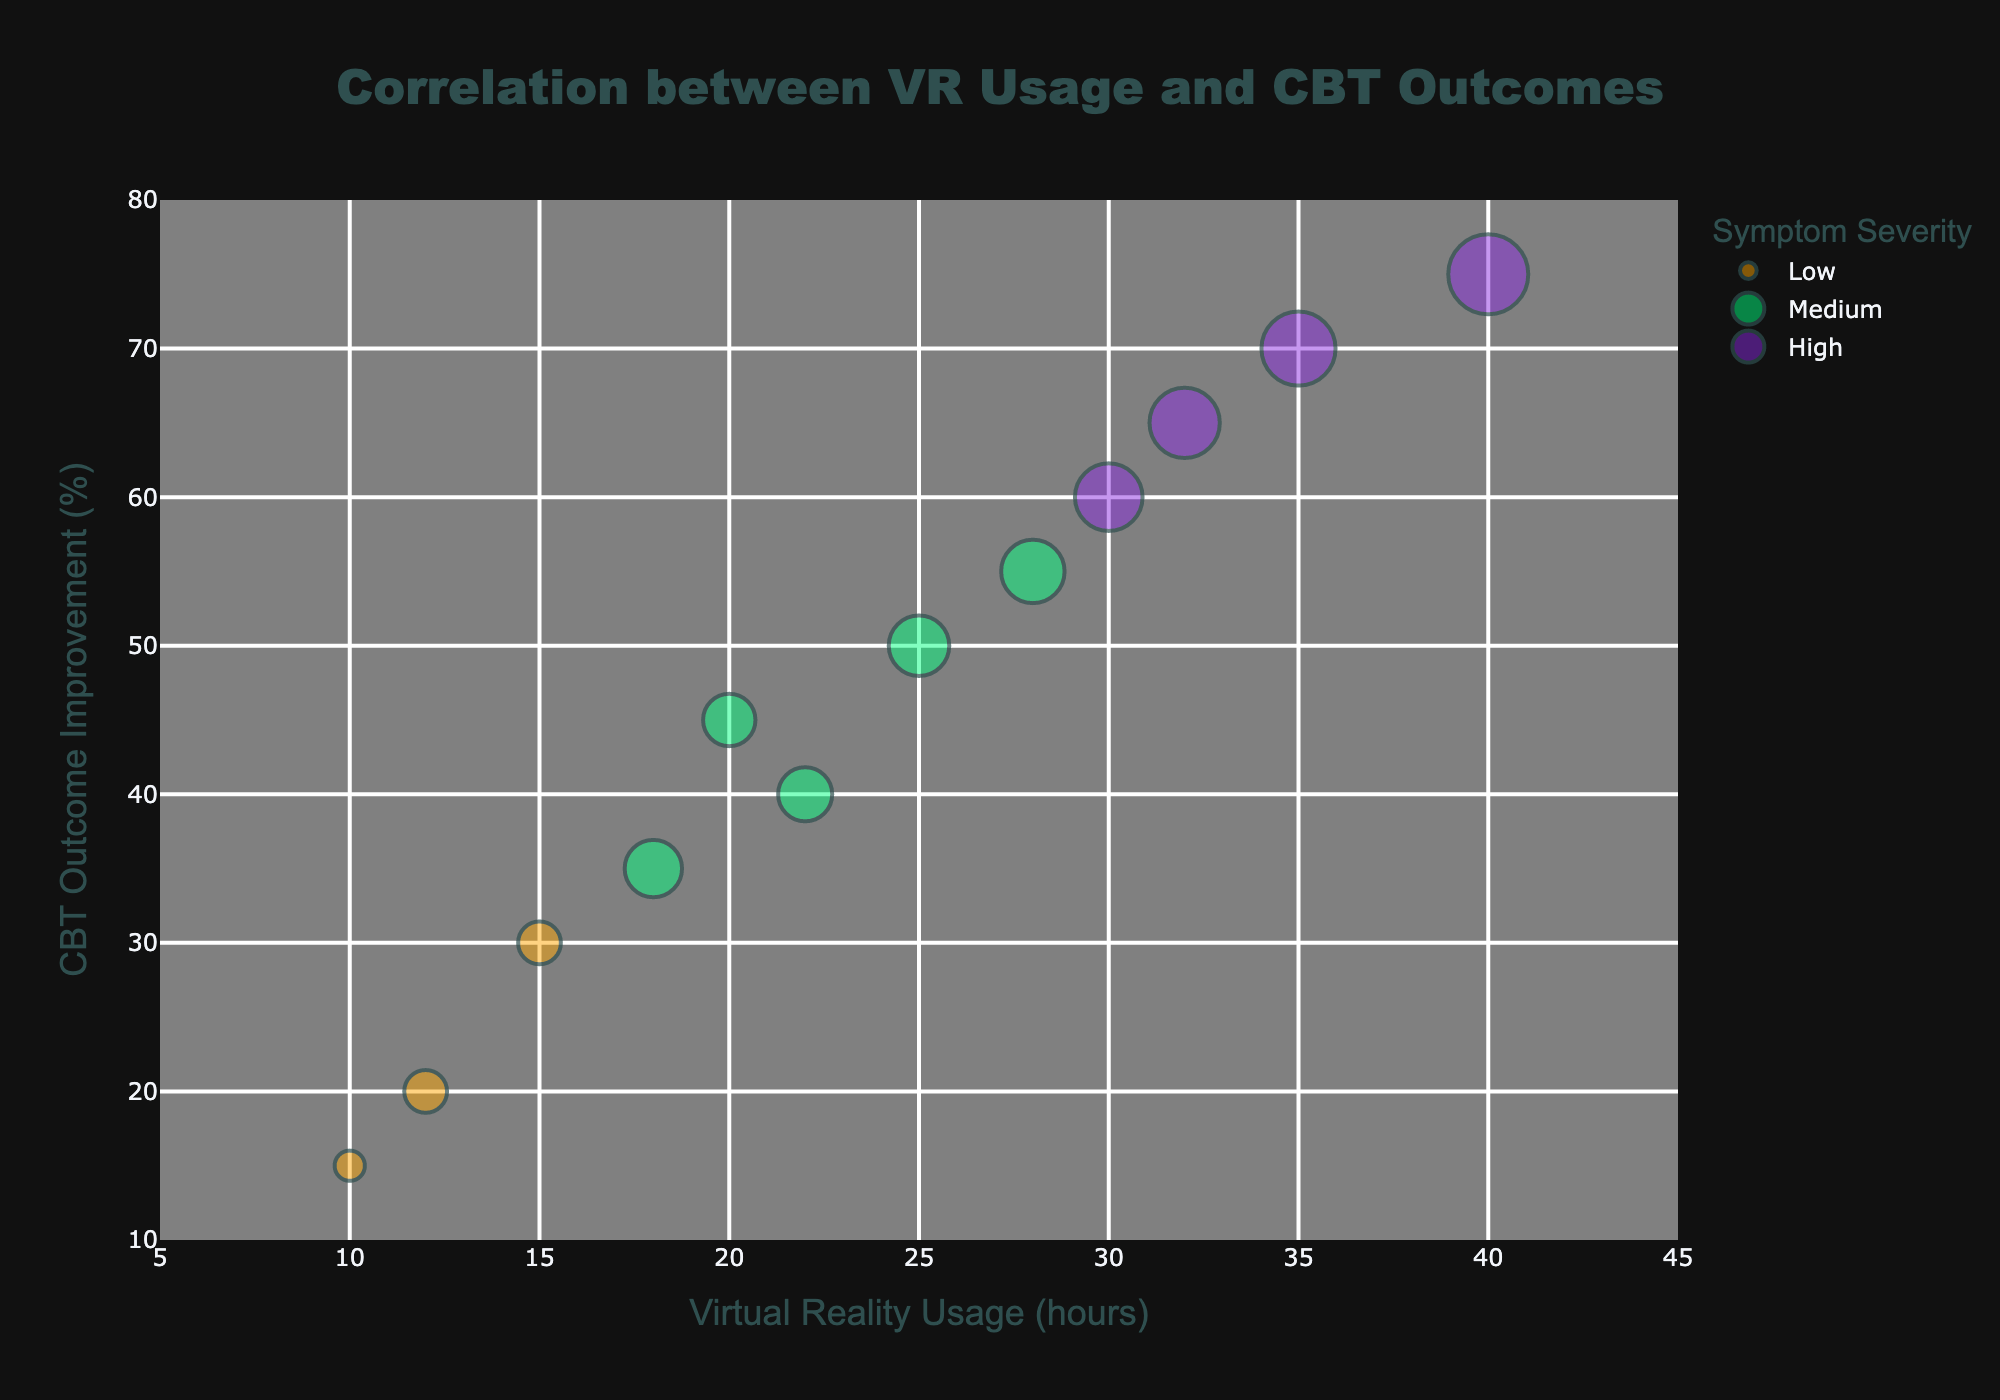How many data points are in the chart? By counting the bubbles on the chart, we determine the total number of data points. Each bubble represents one data point.
Answer: 12 What is the title of the chart? The title of the chart is displayed prominently at the top of the figure.
Answer: Correlation between VR Usage and CBT Outcomes Which symptom severity has the largest bubble size? By inspecting the different bubble sizes and their respective legends, we can identify the category that has the largest bubble size.
Answer: High What is the VR usage for the data point labeled 'Moderate Anxiety' with the highest CBT outcome improvement? By finding the data point with the label 'Moderate Anxiety' and the highest CBT outcome improvement, we can read off the corresponding VR usage from the x-axis.
Answer: 25 Which data point shows the greatest improvement in CBT outcomes? By identifying the highest position on the y-axis where a bubble is located, we find the data point with the greatest improvement in CBT outcomes.
Answer: 40 VR Usage, High symptom severity What is the average CBT outcome improvement for the 'Medium' symptom severity group? Sum the CBT outcome improvements for data points in the 'Medium' severity group and divide by the number of points in that group. (45 + 50 + 35 + 40 + 55)/5 = 225/5
Answer: 45 Compare the VR usage between 'Severe Depression' and 'Severe Anxiety' for High symptom severity? We locate the data points under High symptom severity for 'Severe Depression' and 'Severe Anxiety'. Then we compare their VR usage values.
Answer: 'Severe Depression' has higher VR usage What is the overall trend between VR usage and CBT outcome improvement? By examining the general pattern in the bubble positions, we can identify if there's an increasing, decreasing, or no trend.
Answer: Increasing How does symptom severity correlate with bubble size? Analyze the bubble sizes corresponding to each symptom severity to determine the relationship.
Answer: Higher severity correlates with larger bubbles What is the average VR usage for 'High' symptom severity category? Sum the VR usage values for data points in the 'High' severity group and divide by the number of points in that group. (30 + 35 + 32 + 40)/4 = 137/4
Answer: 34.25 